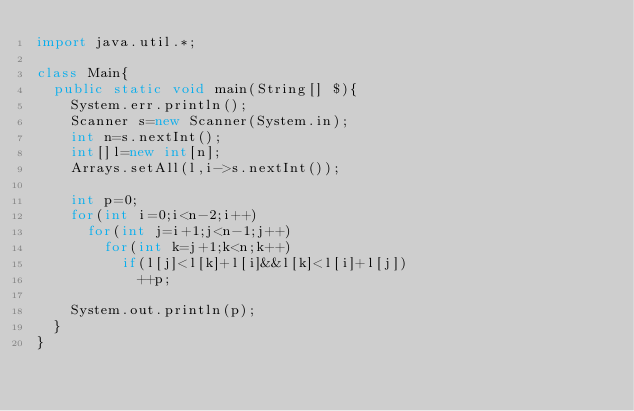Convert code to text. <code><loc_0><loc_0><loc_500><loc_500><_Java_>import java.util.*;

class Main{
	public static void main(String[] $){
		System.err.println();
		Scanner s=new Scanner(System.in);
		int n=s.nextInt();
		int[]l=new int[n];
		Arrays.setAll(l,i->s.nextInt());

		int p=0;
		for(int i=0;i<n-2;i++)
			for(int j=i+1;j<n-1;j++)
				for(int k=j+1;k<n;k++)
					if(l[j]<l[k]+l[i]&&l[k]<l[i]+l[j])
						++p;

		System.out.println(p);
	}
}
</code> 